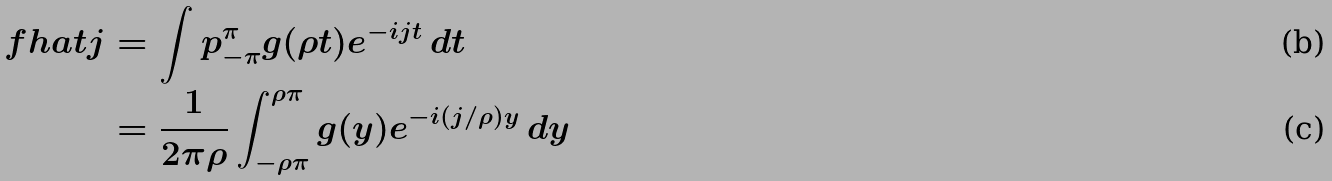Convert formula to latex. <formula><loc_0><loc_0><loc_500><loc_500>\ f h a t j & = \int p _ { - \pi } ^ { \pi } g ( \rho t ) e ^ { - i j t } \, d t \\ & = \frac { 1 } { 2 \pi \rho } \int _ { - \rho \pi } ^ { \rho \pi } g ( y ) e ^ { - i ( j / \rho ) y } \, d y</formula> 